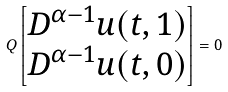<formula> <loc_0><loc_0><loc_500><loc_500>Q \begin{bmatrix} D ^ { \alpha - 1 } u ( t , 1 ) \\ D ^ { \alpha - 1 } u ( t , 0 ) \end{bmatrix} = 0</formula> 